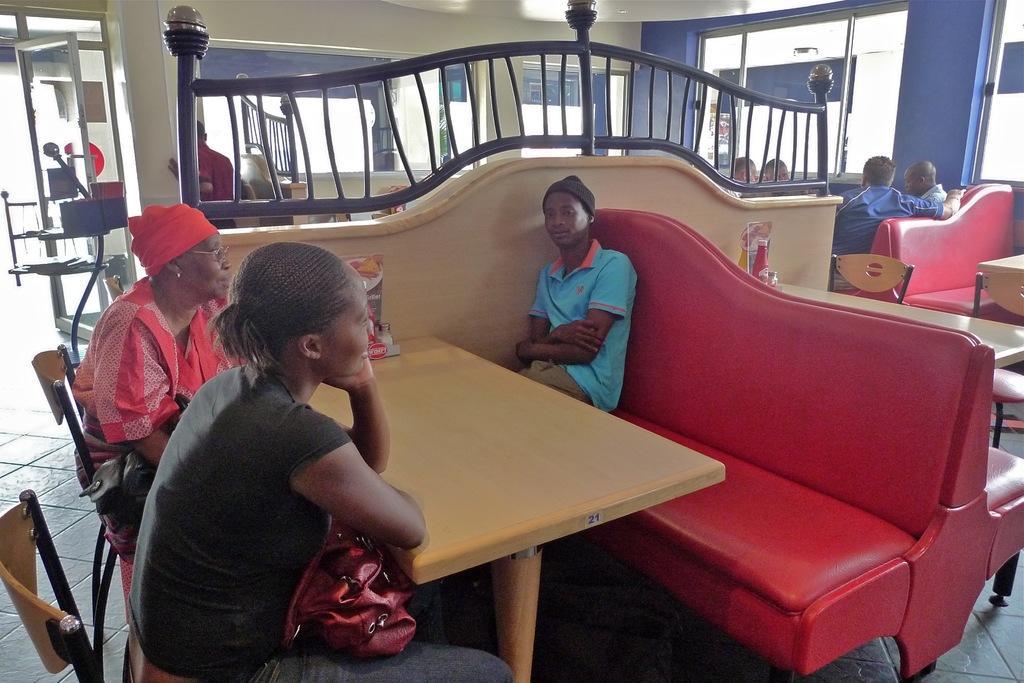Can you describe this image briefly? Here we can see three persons are sitting on the chairs. This is table. And there is a pillar. Here we can see a glass and this is floor. 